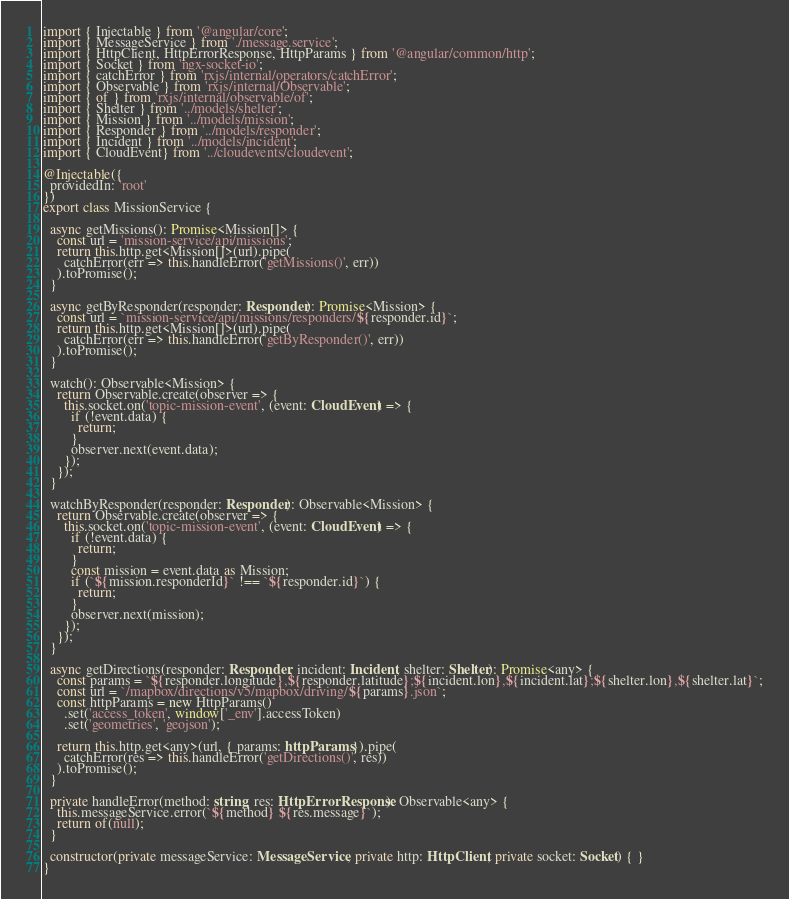<code> <loc_0><loc_0><loc_500><loc_500><_TypeScript_>import { Injectable } from '@angular/core';
import { MessageService } from './message.service';
import { HttpClient, HttpErrorResponse, HttpParams } from '@angular/common/http';
import { Socket } from 'ngx-socket-io';
import { catchError } from 'rxjs/internal/operators/catchError';
import { Observable } from 'rxjs/internal/Observable';
import { of } from 'rxjs/internal/observable/of';
import { Shelter } from '../models/shelter';
import { Mission } from '../models/mission';
import { Responder } from '../models/responder';
import { Incident } from '../models/incident';
import { CloudEvent} from '../cloudevents/cloudevent';

@Injectable({
  providedIn: 'root'
})
export class MissionService {

  async getMissions(): Promise<Mission[]> {
    const url = 'mission-service/api/missions';
    return this.http.get<Mission[]>(url).pipe(
      catchError(err => this.handleError('getMissions()', err))
    ).toPromise();
  }

  async getByResponder(responder: Responder): Promise<Mission> {
    const url = `mission-service/api/missions/responders/${responder.id}`;
    return this.http.get<Mission[]>(url).pipe(
      catchError(err => this.handleError('getByResponder()', err))
    ).toPromise();
  }

  watch(): Observable<Mission> {
    return Observable.create(observer => {
      this.socket.on('topic-mission-event', (event: CloudEvent) => {
        if (!event.data) {
          return;
        }        
        observer.next(event.data);
      });
    });
  }

  watchByResponder(responder: Responder): Observable<Mission> {
    return Observable.create(observer => {
      this.socket.on('topic-mission-event', (event: CloudEvent) => {
        if (!event.data) {
          return;
        }
        const mission = event.data as Mission;
        if (`${mission.responderId}` !== `${responder.id}`) {
          return;
        }
        observer.next(mission);
      });
    });
  }

  async getDirections(responder: Responder, incident: Incident, shelter: Shelter): Promise<any> {
    const params = `${responder.longitude},${responder.latitude};${incident.lon},${incident.lat};${shelter.lon},${shelter.lat}`;
    const url = `/mapbox/directions/v5/mapbox/driving/${params}.json`;
    const httpParams = new HttpParams()
      .set('access_token', window['_env'].accessToken)
      .set('geometries', 'geojson');

    return this.http.get<any>(url, { params: httpParams }).pipe(
      catchError(res => this.handleError('getDirections()', res))
    ).toPromise();
  }

  private handleError(method: string, res: HttpErrorResponse): Observable<any> {
    this.messageService.error(`${method} ${res.message}`);
    return of(null);
  }

  constructor(private messageService: MessageService, private http: HttpClient, private socket: Socket) { }
}
</code> 